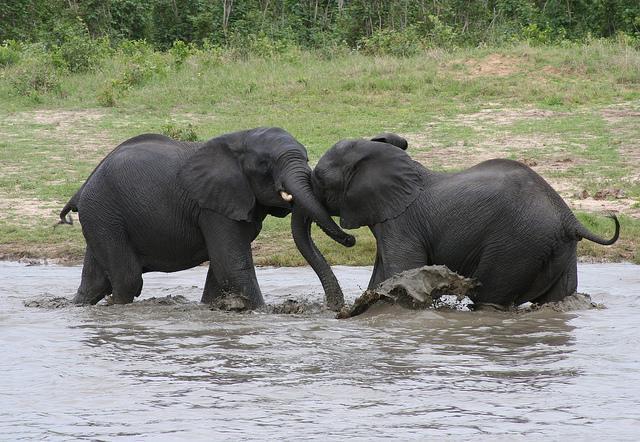How many elephants are in the picture?
Give a very brief answer. 2. How many elephants are there?
Give a very brief answer. 2. 